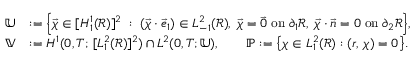Convert formula to latex. <formula><loc_0><loc_0><loc_500><loc_500>\begin{array} { r l } { \mathbb { U } } & { \colon = \left \{ \vec { \chi } \in [ H _ { 1 } ^ { 1 } ( \ m a t h s c r { R } ) ] ^ { 2 } \, \colon \, ( \vec { \chi } \cdot \vec { e } _ { 1 } ) \in L _ { - 1 } ^ { 2 } ( \ m a t h s c r { R } ) , \, \vec { \chi } = \vec { 0 } \, o n \, \partial _ { 1 } \ m a t h s c r { R } , \, \vec { \chi } \cdot \vec { n } = 0 \, o n \, \partial _ { 2 } \ m a t h s c r { R } \right \} , } \\ { \mathbb { V } } & { \colon = H ^ { 1 } ( 0 , T ; \, [ L _ { 1 } ^ { 2 } ( \ m a t h s c r { R } ) ] ^ { 2 } ) \cap L ^ { 2 } ( 0 , T ; \mathbb { U } ) , \quad { \mathbb { P } } \colon = \left \{ \chi \in L _ { 1 } ^ { 2 } ( \ m a t h s c r { R } ) \colon ( r , \, \chi ) = 0 \right \} . } \end{array}</formula> 